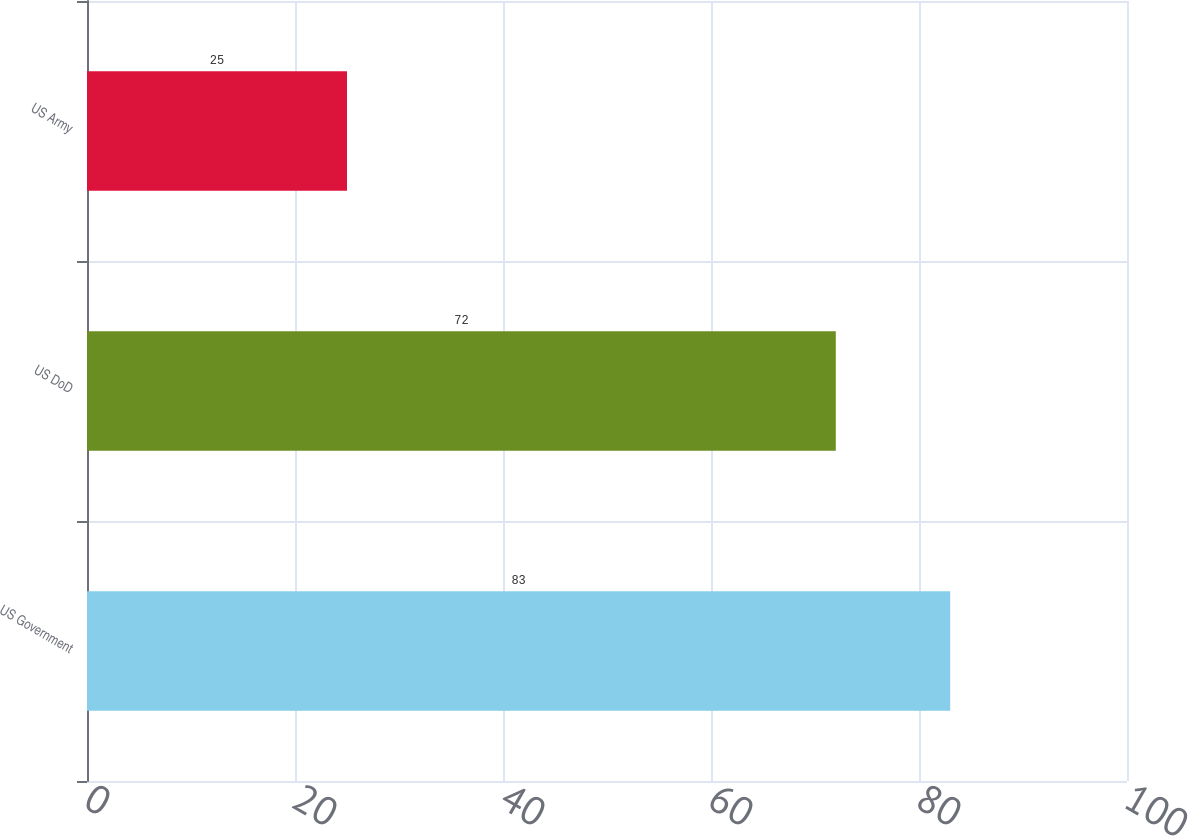Convert chart. <chart><loc_0><loc_0><loc_500><loc_500><bar_chart><fcel>US Government<fcel>US DoD<fcel>US Army<nl><fcel>83<fcel>72<fcel>25<nl></chart> 